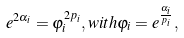Convert formula to latex. <formula><loc_0><loc_0><loc_500><loc_500>e ^ { 2 \alpha _ { i } } = \varphi _ { i } ^ { 2 p _ { i } } , w i t h \varphi _ { i } = e ^ { \frac { \alpha _ { i } } { p _ { i } } } ,</formula> 